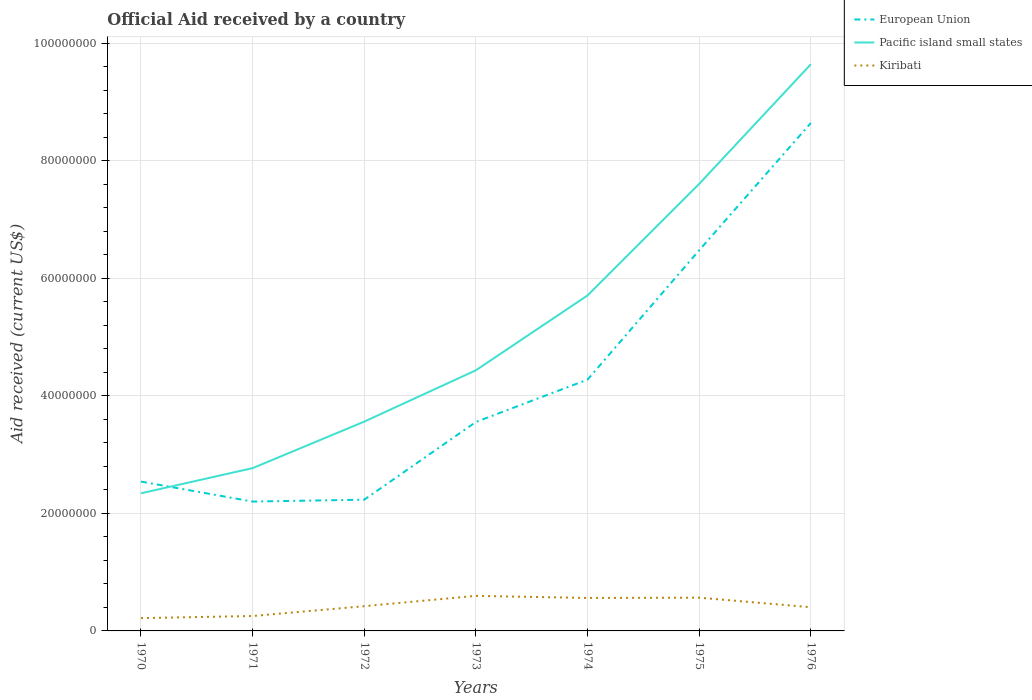Is the number of lines equal to the number of legend labels?
Offer a very short reply. Yes. Across all years, what is the maximum net official aid received in Kiribati?
Ensure brevity in your answer.  2.18e+06. In which year was the net official aid received in European Union maximum?
Ensure brevity in your answer.  1971. What is the total net official aid received in Kiribati in the graph?
Your answer should be compact. -2.03e+06. What is the difference between the highest and the second highest net official aid received in European Union?
Your response must be concise. 6.44e+07. How many lines are there?
Your response must be concise. 3. Does the graph contain any zero values?
Give a very brief answer. No. Does the graph contain grids?
Make the answer very short. Yes. Where does the legend appear in the graph?
Keep it short and to the point. Top right. How many legend labels are there?
Make the answer very short. 3. How are the legend labels stacked?
Make the answer very short. Vertical. What is the title of the graph?
Ensure brevity in your answer.  Official Aid received by a country. Does "Ukraine" appear as one of the legend labels in the graph?
Offer a very short reply. No. What is the label or title of the X-axis?
Your answer should be very brief. Years. What is the label or title of the Y-axis?
Make the answer very short. Aid received (current US$). What is the Aid received (current US$) in European Union in 1970?
Keep it short and to the point. 2.54e+07. What is the Aid received (current US$) in Pacific island small states in 1970?
Provide a succinct answer. 2.34e+07. What is the Aid received (current US$) in Kiribati in 1970?
Keep it short and to the point. 2.18e+06. What is the Aid received (current US$) in European Union in 1971?
Your answer should be very brief. 2.20e+07. What is the Aid received (current US$) of Pacific island small states in 1971?
Offer a terse response. 2.77e+07. What is the Aid received (current US$) of Kiribati in 1971?
Provide a short and direct response. 2.54e+06. What is the Aid received (current US$) of European Union in 1972?
Your response must be concise. 2.23e+07. What is the Aid received (current US$) of Pacific island small states in 1972?
Provide a short and direct response. 3.56e+07. What is the Aid received (current US$) in Kiribati in 1972?
Keep it short and to the point. 4.21e+06. What is the Aid received (current US$) of European Union in 1973?
Your answer should be very brief. 3.56e+07. What is the Aid received (current US$) of Pacific island small states in 1973?
Offer a very short reply. 4.44e+07. What is the Aid received (current US$) of Kiribati in 1973?
Ensure brevity in your answer.  5.97e+06. What is the Aid received (current US$) of European Union in 1974?
Your answer should be very brief. 4.28e+07. What is the Aid received (current US$) of Pacific island small states in 1974?
Ensure brevity in your answer.  5.71e+07. What is the Aid received (current US$) in Kiribati in 1974?
Provide a short and direct response. 5.61e+06. What is the Aid received (current US$) of European Union in 1975?
Your answer should be compact. 6.48e+07. What is the Aid received (current US$) in Pacific island small states in 1975?
Your answer should be very brief. 7.61e+07. What is the Aid received (current US$) in Kiribati in 1975?
Give a very brief answer. 5.66e+06. What is the Aid received (current US$) of European Union in 1976?
Your answer should be compact. 8.65e+07. What is the Aid received (current US$) of Pacific island small states in 1976?
Make the answer very short. 9.65e+07. What is the Aid received (current US$) of Kiribati in 1976?
Provide a succinct answer. 4.03e+06. Across all years, what is the maximum Aid received (current US$) of European Union?
Provide a succinct answer. 8.65e+07. Across all years, what is the maximum Aid received (current US$) of Pacific island small states?
Offer a very short reply. 9.65e+07. Across all years, what is the maximum Aid received (current US$) of Kiribati?
Your answer should be compact. 5.97e+06. Across all years, what is the minimum Aid received (current US$) of European Union?
Make the answer very short. 2.20e+07. Across all years, what is the minimum Aid received (current US$) of Pacific island small states?
Ensure brevity in your answer.  2.34e+07. Across all years, what is the minimum Aid received (current US$) of Kiribati?
Give a very brief answer. 2.18e+06. What is the total Aid received (current US$) in European Union in the graph?
Your response must be concise. 2.99e+08. What is the total Aid received (current US$) in Pacific island small states in the graph?
Your answer should be very brief. 3.61e+08. What is the total Aid received (current US$) in Kiribati in the graph?
Your response must be concise. 3.02e+07. What is the difference between the Aid received (current US$) in European Union in 1970 and that in 1971?
Keep it short and to the point. 3.40e+06. What is the difference between the Aid received (current US$) of Pacific island small states in 1970 and that in 1971?
Give a very brief answer. -4.28e+06. What is the difference between the Aid received (current US$) of Kiribati in 1970 and that in 1971?
Ensure brevity in your answer.  -3.60e+05. What is the difference between the Aid received (current US$) in European Union in 1970 and that in 1972?
Ensure brevity in your answer.  3.08e+06. What is the difference between the Aid received (current US$) in Pacific island small states in 1970 and that in 1972?
Your answer should be compact. -1.22e+07. What is the difference between the Aid received (current US$) in Kiribati in 1970 and that in 1972?
Make the answer very short. -2.03e+06. What is the difference between the Aid received (current US$) in European Union in 1970 and that in 1973?
Your response must be concise. -1.02e+07. What is the difference between the Aid received (current US$) in Pacific island small states in 1970 and that in 1973?
Provide a succinct answer. -2.09e+07. What is the difference between the Aid received (current US$) in Kiribati in 1970 and that in 1973?
Keep it short and to the point. -3.79e+06. What is the difference between the Aid received (current US$) of European Union in 1970 and that in 1974?
Your answer should be very brief. -1.74e+07. What is the difference between the Aid received (current US$) in Pacific island small states in 1970 and that in 1974?
Your answer should be very brief. -3.37e+07. What is the difference between the Aid received (current US$) in Kiribati in 1970 and that in 1974?
Your response must be concise. -3.43e+06. What is the difference between the Aid received (current US$) of European Union in 1970 and that in 1975?
Offer a terse response. -3.94e+07. What is the difference between the Aid received (current US$) of Pacific island small states in 1970 and that in 1975?
Provide a succinct answer. -5.27e+07. What is the difference between the Aid received (current US$) of Kiribati in 1970 and that in 1975?
Offer a terse response. -3.48e+06. What is the difference between the Aid received (current US$) of European Union in 1970 and that in 1976?
Make the answer very short. -6.10e+07. What is the difference between the Aid received (current US$) in Pacific island small states in 1970 and that in 1976?
Your response must be concise. -7.30e+07. What is the difference between the Aid received (current US$) in Kiribati in 1970 and that in 1976?
Provide a short and direct response. -1.85e+06. What is the difference between the Aid received (current US$) in European Union in 1971 and that in 1972?
Your answer should be very brief. -3.20e+05. What is the difference between the Aid received (current US$) of Pacific island small states in 1971 and that in 1972?
Ensure brevity in your answer.  -7.92e+06. What is the difference between the Aid received (current US$) of Kiribati in 1971 and that in 1972?
Provide a short and direct response. -1.67e+06. What is the difference between the Aid received (current US$) in European Union in 1971 and that in 1973?
Offer a terse response. -1.36e+07. What is the difference between the Aid received (current US$) in Pacific island small states in 1971 and that in 1973?
Give a very brief answer. -1.67e+07. What is the difference between the Aid received (current US$) of Kiribati in 1971 and that in 1973?
Keep it short and to the point. -3.43e+06. What is the difference between the Aid received (current US$) in European Union in 1971 and that in 1974?
Keep it short and to the point. -2.08e+07. What is the difference between the Aid received (current US$) in Pacific island small states in 1971 and that in 1974?
Your answer should be compact. -2.94e+07. What is the difference between the Aid received (current US$) in Kiribati in 1971 and that in 1974?
Offer a very short reply. -3.07e+06. What is the difference between the Aid received (current US$) of European Union in 1971 and that in 1975?
Give a very brief answer. -4.28e+07. What is the difference between the Aid received (current US$) of Pacific island small states in 1971 and that in 1975?
Give a very brief answer. -4.84e+07. What is the difference between the Aid received (current US$) in Kiribati in 1971 and that in 1975?
Your answer should be compact. -3.12e+06. What is the difference between the Aid received (current US$) in European Union in 1971 and that in 1976?
Provide a succinct answer. -6.44e+07. What is the difference between the Aid received (current US$) in Pacific island small states in 1971 and that in 1976?
Provide a succinct answer. -6.88e+07. What is the difference between the Aid received (current US$) of Kiribati in 1971 and that in 1976?
Keep it short and to the point. -1.49e+06. What is the difference between the Aid received (current US$) of European Union in 1972 and that in 1973?
Make the answer very short. -1.32e+07. What is the difference between the Aid received (current US$) in Pacific island small states in 1972 and that in 1973?
Your answer should be compact. -8.74e+06. What is the difference between the Aid received (current US$) in Kiribati in 1972 and that in 1973?
Provide a succinct answer. -1.76e+06. What is the difference between the Aid received (current US$) in European Union in 1972 and that in 1974?
Keep it short and to the point. -2.04e+07. What is the difference between the Aid received (current US$) of Pacific island small states in 1972 and that in 1974?
Your answer should be very brief. -2.15e+07. What is the difference between the Aid received (current US$) in Kiribati in 1972 and that in 1974?
Your response must be concise. -1.40e+06. What is the difference between the Aid received (current US$) of European Union in 1972 and that in 1975?
Give a very brief answer. -4.25e+07. What is the difference between the Aid received (current US$) of Pacific island small states in 1972 and that in 1975?
Your answer should be compact. -4.05e+07. What is the difference between the Aid received (current US$) in Kiribati in 1972 and that in 1975?
Give a very brief answer. -1.45e+06. What is the difference between the Aid received (current US$) in European Union in 1972 and that in 1976?
Ensure brevity in your answer.  -6.41e+07. What is the difference between the Aid received (current US$) of Pacific island small states in 1972 and that in 1976?
Provide a succinct answer. -6.08e+07. What is the difference between the Aid received (current US$) in Kiribati in 1972 and that in 1976?
Your response must be concise. 1.80e+05. What is the difference between the Aid received (current US$) in European Union in 1973 and that in 1974?
Your answer should be very brief. -7.21e+06. What is the difference between the Aid received (current US$) of Pacific island small states in 1973 and that in 1974?
Provide a succinct answer. -1.27e+07. What is the difference between the Aid received (current US$) in European Union in 1973 and that in 1975?
Keep it short and to the point. -2.92e+07. What is the difference between the Aid received (current US$) of Pacific island small states in 1973 and that in 1975?
Your response must be concise. -3.17e+07. What is the difference between the Aid received (current US$) of Kiribati in 1973 and that in 1975?
Give a very brief answer. 3.10e+05. What is the difference between the Aid received (current US$) in European Union in 1973 and that in 1976?
Give a very brief answer. -5.09e+07. What is the difference between the Aid received (current US$) in Pacific island small states in 1973 and that in 1976?
Ensure brevity in your answer.  -5.21e+07. What is the difference between the Aid received (current US$) in Kiribati in 1973 and that in 1976?
Provide a short and direct response. 1.94e+06. What is the difference between the Aid received (current US$) in European Union in 1974 and that in 1975?
Offer a very short reply. -2.20e+07. What is the difference between the Aid received (current US$) in Pacific island small states in 1974 and that in 1975?
Offer a terse response. -1.90e+07. What is the difference between the Aid received (current US$) in Kiribati in 1974 and that in 1975?
Your response must be concise. -5.00e+04. What is the difference between the Aid received (current US$) in European Union in 1974 and that in 1976?
Make the answer very short. -4.37e+07. What is the difference between the Aid received (current US$) in Pacific island small states in 1974 and that in 1976?
Your answer should be compact. -3.94e+07. What is the difference between the Aid received (current US$) in Kiribati in 1974 and that in 1976?
Offer a very short reply. 1.58e+06. What is the difference between the Aid received (current US$) in European Union in 1975 and that in 1976?
Give a very brief answer. -2.17e+07. What is the difference between the Aid received (current US$) in Pacific island small states in 1975 and that in 1976?
Your answer should be compact. -2.04e+07. What is the difference between the Aid received (current US$) in Kiribati in 1975 and that in 1976?
Provide a succinct answer. 1.63e+06. What is the difference between the Aid received (current US$) in European Union in 1970 and the Aid received (current US$) in Pacific island small states in 1971?
Your answer should be very brief. -2.29e+06. What is the difference between the Aid received (current US$) in European Union in 1970 and the Aid received (current US$) in Kiribati in 1971?
Your answer should be very brief. 2.29e+07. What is the difference between the Aid received (current US$) of Pacific island small states in 1970 and the Aid received (current US$) of Kiribati in 1971?
Provide a succinct answer. 2.09e+07. What is the difference between the Aid received (current US$) in European Union in 1970 and the Aid received (current US$) in Pacific island small states in 1972?
Provide a short and direct response. -1.02e+07. What is the difference between the Aid received (current US$) of European Union in 1970 and the Aid received (current US$) of Kiribati in 1972?
Offer a terse response. 2.12e+07. What is the difference between the Aid received (current US$) of Pacific island small states in 1970 and the Aid received (current US$) of Kiribati in 1972?
Ensure brevity in your answer.  1.92e+07. What is the difference between the Aid received (current US$) in European Union in 1970 and the Aid received (current US$) in Pacific island small states in 1973?
Your response must be concise. -1.90e+07. What is the difference between the Aid received (current US$) of European Union in 1970 and the Aid received (current US$) of Kiribati in 1973?
Keep it short and to the point. 1.94e+07. What is the difference between the Aid received (current US$) in Pacific island small states in 1970 and the Aid received (current US$) in Kiribati in 1973?
Make the answer very short. 1.75e+07. What is the difference between the Aid received (current US$) in European Union in 1970 and the Aid received (current US$) in Pacific island small states in 1974?
Offer a very short reply. -3.17e+07. What is the difference between the Aid received (current US$) in European Union in 1970 and the Aid received (current US$) in Kiribati in 1974?
Keep it short and to the point. 1.98e+07. What is the difference between the Aid received (current US$) of Pacific island small states in 1970 and the Aid received (current US$) of Kiribati in 1974?
Give a very brief answer. 1.78e+07. What is the difference between the Aid received (current US$) of European Union in 1970 and the Aid received (current US$) of Pacific island small states in 1975?
Provide a short and direct response. -5.07e+07. What is the difference between the Aid received (current US$) in European Union in 1970 and the Aid received (current US$) in Kiribati in 1975?
Your answer should be very brief. 1.98e+07. What is the difference between the Aid received (current US$) of Pacific island small states in 1970 and the Aid received (current US$) of Kiribati in 1975?
Ensure brevity in your answer.  1.78e+07. What is the difference between the Aid received (current US$) of European Union in 1970 and the Aid received (current US$) of Pacific island small states in 1976?
Ensure brevity in your answer.  -7.10e+07. What is the difference between the Aid received (current US$) in European Union in 1970 and the Aid received (current US$) in Kiribati in 1976?
Make the answer very short. 2.14e+07. What is the difference between the Aid received (current US$) of Pacific island small states in 1970 and the Aid received (current US$) of Kiribati in 1976?
Your answer should be compact. 1.94e+07. What is the difference between the Aid received (current US$) in European Union in 1971 and the Aid received (current US$) in Pacific island small states in 1972?
Your answer should be very brief. -1.36e+07. What is the difference between the Aid received (current US$) in European Union in 1971 and the Aid received (current US$) in Kiribati in 1972?
Keep it short and to the point. 1.78e+07. What is the difference between the Aid received (current US$) of Pacific island small states in 1971 and the Aid received (current US$) of Kiribati in 1972?
Keep it short and to the point. 2.35e+07. What is the difference between the Aid received (current US$) in European Union in 1971 and the Aid received (current US$) in Pacific island small states in 1973?
Offer a terse response. -2.24e+07. What is the difference between the Aid received (current US$) in European Union in 1971 and the Aid received (current US$) in Kiribati in 1973?
Make the answer very short. 1.60e+07. What is the difference between the Aid received (current US$) of Pacific island small states in 1971 and the Aid received (current US$) of Kiribati in 1973?
Provide a succinct answer. 2.17e+07. What is the difference between the Aid received (current US$) in European Union in 1971 and the Aid received (current US$) in Pacific island small states in 1974?
Offer a very short reply. -3.51e+07. What is the difference between the Aid received (current US$) in European Union in 1971 and the Aid received (current US$) in Kiribati in 1974?
Your answer should be very brief. 1.64e+07. What is the difference between the Aid received (current US$) of Pacific island small states in 1971 and the Aid received (current US$) of Kiribati in 1974?
Your answer should be very brief. 2.21e+07. What is the difference between the Aid received (current US$) in European Union in 1971 and the Aid received (current US$) in Pacific island small states in 1975?
Provide a succinct answer. -5.41e+07. What is the difference between the Aid received (current US$) in European Union in 1971 and the Aid received (current US$) in Kiribati in 1975?
Make the answer very short. 1.64e+07. What is the difference between the Aid received (current US$) in Pacific island small states in 1971 and the Aid received (current US$) in Kiribati in 1975?
Give a very brief answer. 2.20e+07. What is the difference between the Aid received (current US$) of European Union in 1971 and the Aid received (current US$) of Pacific island small states in 1976?
Offer a very short reply. -7.44e+07. What is the difference between the Aid received (current US$) in European Union in 1971 and the Aid received (current US$) in Kiribati in 1976?
Provide a succinct answer. 1.80e+07. What is the difference between the Aid received (current US$) of Pacific island small states in 1971 and the Aid received (current US$) of Kiribati in 1976?
Provide a succinct answer. 2.37e+07. What is the difference between the Aid received (current US$) of European Union in 1972 and the Aid received (current US$) of Pacific island small states in 1973?
Ensure brevity in your answer.  -2.20e+07. What is the difference between the Aid received (current US$) in European Union in 1972 and the Aid received (current US$) in Kiribati in 1973?
Provide a short and direct response. 1.64e+07. What is the difference between the Aid received (current US$) of Pacific island small states in 1972 and the Aid received (current US$) of Kiribati in 1973?
Provide a short and direct response. 2.97e+07. What is the difference between the Aid received (current US$) of European Union in 1972 and the Aid received (current US$) of Pacific island small states in 1974?
Keep it short and to the point. -3.48e+07. What is the difference between the Aid received (current US$) of European Union in 1972 and the Aid received (current US$) of Kiribati in 1974?
Keep it short and to the point. 1.67e+07. What is the difference between the Aid received (current US$) in Pacific island small states in 1972 and the Aid received (current US$) in Kiribati in 1974?
Offer a very short reply. 3.00e+07. What is the difference between the Aid received (current US$) in European Union in 1972 and the Aid received (current US$) in Pacific island small states in 1975?
Make the answer very short. -5.38e+07. What is the difference between the Aid received (current US$) in European Union in 1972 and the Aid received (current US$) in Kiribati in 1975?
Your response must be concise. 1.67e+07. What is the difference between the Aid received (current US$) in Pacific island small states in 1972 and the Aid received (current US$) in Kiribati in 1975?
Your answer should be very brief. 3.00e+07. What is the difference between the Aid received (current US$) of European Union in 1972 and the Aid received (current US$) of Pacific island small states in 1976?
Your response must be concise. -7.41e+07. What is the difference between the Aid received (current US$) of European Union in 1972 and the Aid received (current US$) of Kiribati in 1976?
Ensure brevity in your answer.  1.83e+07. What is the difference between the Aid received (current US$) of Pacific island small states in 1972 and the Aid received (current US$) of Kiribati in 1976?
Your response must be concise. 3.16e+07. What is the difference between the Aid received (current US$) in European Union in 1973 and the Aid received (current US$) in Pacific island small states in 1974?
Provide a succinct answer. -2.15e+07. What is the difference between the Aid received (current US$) in European Union in 1973 and the Aid received (current US$) in Kiribati in 1974?
Offer a very short reply. 3.00e+07. What is the difference between the Aid received (current US$) in Pacific island small states in 1973 and the Aid received (current US$) in Kiribati in 1974?
Offer a terse response. 3.88e+07. What is the difference between the Aid received (current US$) in European Union in 1973 and the Aid received (current US$) in Pacific island small states in 1975?
Your answer should be compact. -4.05e+07. What is the difference between the Aid received (current US$) in European Union in 1973 and the Aid received (current US$) in Kiribati in 1975?
Offer a very short reply. 2.99e+07. What is the difference between the Aid received (current US$) of Pacific island small states in 1973 and the Aid received (current US$) of Kiribati in 1975?
Your response must be concise. 3.87e+07. What is the difference between the Aid received (current US$) in European Union in 1973 and the Aid received (current US$) in Pacific island small states in 1976?
Make the answer very short. -6.09e+07. What is the difference between the Aid received (current US$) in European Union in 1973 and the Aid received (current US$) in Kiribati in 1976?
Offer a very short reply. 3.15e+07. What is the difference between the Aid received (current US$) in Pacific island small states in 1973 and the Aid received (current US$) in Kiribati in 1976?
Offer a very short reply. 4.03e+07. What is the difference between the Aid received (current US$) of European Union in 1974 and the Aid received (current US$) of Pacific island small states in 1975?
Give a very brief answer. -3.33e+07. What is the difference between the Aid received (current US$) in European Union in 1974 and the Aid received (current US$) in Kiribati in 1975?
Make the answer very short. 3.71e+07. What is the difference between the Aid received (current US$) of Pacific island small states in 1974 and the Aid received (current US$) of Kiribati in 1975?
Your answer should be very brief. 5.14e+07. What is the difference between the Aid received (current US$) of European Union in 1974 and the Aid received (current US$) of Pacific island small states in 1976?
Offer a very short reply. -5.37e+07. What is the difference between the Aid received (current US$) in European Union in 1974 and the Aid received (current US$) in Kiribati in 1976?
Keep it short and to the point. 3.88e+07. What is the difference between the Aid received (current US$) in Pacific island small states in 1974 and the Aid received (current US$) in Kiribati in 1976?
Offer a terse response. 5.31e+07. What is the difference between the Aid received (current US$) of European Union in 1975 and the Aid received (current US$) of Pacific island small states in 1976?
Keep it short and to the point. -3.17e+07. What is the difference between the Aid received (current US$) in European Union in 1975 and the Aid received (current US$) in Kiribati in 1976?
Your answer should be very brief. 6.08e+07. What is the difference between the Aid received (current US$) in Pacific island small states in 1975 and the Aid received (current US$) in Kiribati in 1976?
Keep it short and to the point. 7.21e+07. What is the average Aid received (current US$) of European Union per year?
Keep it short and to the point. 4.28e+07. What is the average Aid received (current US$) of Pacific island small states per year?
Offer a very short reply. 5.15e+07. What is the average Aid received (current US$) in Kiribati per year?
Make the answer very short. 4.31e+06. In the year 1970, what is the difference between the Aid received (current US$) in European Union and Aid received (current US$) in Pacific island small states?
Ensure brevity in your answer.  1.99e+06. In the year 1970, what is the difference between the Aid received (current US$) in European Union and Aid received (current US$) in Kiribati?
Make the answer very short. 2.32e+07. In the year 1970, what is the difference between the Aid received (current US$) in Pacific island small states and Aid received (current US$) in Kiribati?
Provide a succinct answer. 2.12e+07. In the year 1971, what is the difference between the Aid received (current US$) in European Union and Aid received (current US$) in Pacific island small states?
Give a very brief answer. -5.69e+06. In the year 1971, what is the difference between the Aid received (current US$) in European Union and Aid received (current US$) in Kiribati?
Provide a succinct answer. 1.95e+07. In the year 1971, what is the difference between the Aid received (current US$) in Pacific island small states and Aid received (current US$) in Kiribati?
Give a very brief answer. 2.52e+07. In the year 1972, what is the difference between the Aid received (current US$) of European Union and Aid received (current US$) of Pacific island small states?
Make the answer very short. -1.33e+07. In the year 1972, what is the difference between the Aid received (current US$) in European Union and Aid received (current US$) in Kiribati?
Offer a terse response. 1.81e+07. In the year 1972, what is the difference between the Aid received (current US$) in Pacific island small states and Aid received (current US$) in Kiribati?
Your answer should be compact. 3.14e+07. In the year 1973, what is the difference between the Aid received (current US$) in European Union and Aid received (current US$) in Pacific island small states?
Your response must be concise. -8.80e+06. In the year 1973, what is the difference between the Aid received (current US$) of European Union and Aid received (current US$) of Kiribati?
Provide a succinct answer. 2.96e+07. In the year 1973, what is the difference between the Aid received (current US$) in Pacific island small states and Aid received (current US$) in Kiribati?
Offer a very short reply. 3.84e+07. In the year 1974, what is the difference between the Aid received (current US$) in European Union and Aid received (current US$) in Pacific island small states?
Ensure brevity in your answer.  -1.43e+07. In the year 1974, what is the difference between the Aid received (current US$) of European Union and Aid received (current US$) of Kiribati?
Offer a very short reply. 3.72e+07. In the year 1974, what is the difference between the Aid received (current US$) in Pacific island small states and Aid received (current US$) in Kiribati?
Make the answer very short. 5.15e+07. In the year 1975, what is the difference between the Aid received (current US$) in European Union and Aid received (current US$) in Pacific island small states?
Make the answer very short. -1.13e+07. In the year 1975, what is the difference between the Aid received (current US$) of European Union and Aid received (current US$) of Kiribati?
Your answer should be very brief. 5.91e+07. In the year 1975, what is the difference between the Aid received (current US$) of Pacific island small states and Aid received (current US$) of Kiribati?
Your answer should be compact. 7.04e+07. In the year 1976, what is the difference between the Aid received (current US$) in European Union and Aid received (current US$) in Pacific island small states?
Make the answer very short. -1.00e+07. In the year 1976, what is the difference between the Aid received (current US$) of European Union and Aid received (current US$) of Kiribati?
Offer a terse response. 8.24e+07. In the year 1976, what is the difference between the Aid received (current US$) in Pacific island small states and Aid received (current US$) in Kiribati?
Ensure brevity in your answer.  9.24e+07. What is the ratio of the Aid received (current US$) in European Union in 1970 to that in 1971?
Give a very brief answer. 1.15. What is the ratio of the Aid received (current US$) in Pacific island small states in 1970 to that in 1971?
Your answer should be very brief. 0.85. What is the ratio of the Aid received (current US$) in Kiribati in 1970 to that in 1971?
Ensure brevity in your answer.  0.86. What is the ratio of the Aid received (current US$) of European Union in 1970 to that in 1972?
Give a very brief answer. 1.14. What is the ratio of the Aid received (current US$) of Pacific island small states in 1970 to that in 1972?
Ensure brevity in your answer.  0.66. What is the ratio of the Aid received (current US$) in Kiribati in 1970 to that in 1972?
Provide a short and direct response. 0.52. What is the ratio of the Aid received (current US$) in European Union in 1970 to that in 1973?
Keep it short and to the point. 0.71. What is the ratio of the Aid received (current US$) of Pacific island small states in 1970 to that in 1973?
Provide a succinct answer. 0.53. What is the ratio of the Aid received (current US$) of Kiribati in 1970 to that in 1973?
Ensure brevity in your answer.  0.37. What is the ratio of the Aid received (current US$) of European Union in 1970 to that in 1974?
Your response must be concise. 0.59. What is the ratio of the Aid received (current US$) of Pacific island small states in 1970 to that in 1974?
Your answer should be compact. 0.41. What is the ratio of the Aid received (current US$) of Kiribati in 1970 to that in 1974?
Make the answer very short. 0.39. What is the ratio of the Aid received (current US$) in European Union in 1970 to that in 1975?
Your response must be concise. 0.39. What is the ratio of the Aid received (current US$) of Pacific island small states in 1970 to that in 1975?
Your response must be concise. 0.31. What is the ratio of the Aid received (current US$) in Kiribati in 1970 to that in 1975?
Give a very brief answer. 0.39. What is the ratio of the Aid received (current US$) of European Union in 1970 to that in 1976?
Give a very brief answer. 0.29. What is the ratio of the Aid received (current US$) in Pacific island small states in 1970 to that in 1976?
Keep it short and to the point. 0.24. What is the ratio of the Aid received (current US$) in Kiribati in 1970 to that in 1976?
Give a very brief answer. 0.54. What is the ratio of the Aid received (current US$) in European Union in 1971 to that in 1972?
Offer a terse response. 0.99. What is the ratio of the Aid received (current US$) of Pacific island small states in 1971 to that in 1972?
Your response must be concise. 0.78. What is the ratio of the Aid received (current US$) in Kiribati in 1971 to that in 1972?
Provide a short and direct response. 0.6. What is the ratio of the Aid received (current US$) of European Union in 1971 to that in 1973?
Your answer should be compact. 0.62. What is the ratio of the Aid received (current US$) in Pacific island small states in 1971 to that in 1973?
Your response must be concise. 0.62. What is the ratio of the Aid received (current US$) in Kiribati in 1971 to that in 1973?
Ensure brevity in your answer.  0.43. What is the ratio of the Aid received (current US$) of European Union in 1971 to that in 1974?
Provide a succinct answer. 0.51. What is the ratio of the Aid received (current US$) of Pacific island small states in 1971 to that in 1974?
Your answer should be compact. 0.49. What is the ratio of the Aid received (current US$) of Kiribati in 1971 to that in 1974?
Provide a short and direct response. 0.45. What is the ratio of the Aid received (current US$) in European Union in 1971 to that in 1975?
Make the answer very short. 0.34. What is the ratio of the Aid received (current US$) in Pacific island small states in 1971 to that in 1975?
Offer a very short reply. 0.36. What is the ratio of the Aid received (current US$) of Kiribati in 1971 to that in 1975?
Provide a succinct answer. 0.45. What is the ratio of the Aid received (current US$) of European Union in 1971 to that in 1976?
Offer a terse response. 0.25. What is the ratio of the Aid received (current US$) of Pacific island small states in 1971 to that in 1976?
Your answer should be very brief. 0.29. What is the ratio of the Aid received (current US$) in Kiribati in 1971 to that in 1976?
Provide a succinct answer. 0.63. What is the ratio of the Aid received (current US$) in European Union in 1972 to that in 1973?
Provide a succinct answer. 0.63. What is the ratio of the Aid received (current US$) of Pacific island small states in 1972 to that in 1973?
Ensure brevity in your answer.  0.8. What is the ratio of the Aid received (current US$) of Kiribati in 1972 to that in 1973?
Keep it short and to the point. 0.71. What is the ratio of the Aid received (current US$) in European Union in 1972 to that in 1974?
Keep it short and to the point. 0.52. What is the ratio of the Aid received (current US$) in Pacific island small states in 1972 to that in 1974?
Your answer should be compact. 0.62. What is the ratio of the Aid received (current US$) in Kiribati in 1972 to that in 1974?
Provide a short and direct response. 0.75. What is the ratio of the Aid received (current US$) of European Union in 1972 to that in 1975?
Offer a terse response. 0.34. What is the ratio of the Aid received (current US$) in Pacific island small states in 1972 to that in 1975?
Ensure brevity in your answer.  0.47. What is the ratio of the Aid received (current US$) of Kiribati in 1972 to that in 1975?
Provide a succinct answer. 0.74. What is the ratio of the Aid received (current US$) in European Union in 1972 to that in 1976?
Provide a succinct answer. 0.26. What is the ratio of the Aid received (current US$) in Pacific island small states in 1972 to that in 1976?
Keep it short and to the point. 0.37. What is the ratio of the Aid received (current US$) of Kiribati in 1972 to that in 1976?
Your answer should be very brief. 1.04. What is the ratio of the Aid received (current US$) in European Union in 1973 to that in 1974?
Offer a terse response. 0.83. What is the ratio of the Aid received (current US$) in Pacific island small states in 1973 to that in 1974?
Keep it short and to the point. 0.78. What is the ratio of the Aid received (current US$) in Kiribati in 1973 to that in 1974?
Give a very brief answer. 1.06. What is the ratio of the Aid received (current US$) of European Union in 1973 to that in 1975?
Provide a short and direct response. 0.55. What is the ratio of the Aid received (current US$) in Pacific island small states in 1973 to that in 1975?
Give a very brief answer. 0.58. What is the ratio of the Aid received (current US$) in Kiribati in 1973 to that in 1975?
Keep it short and to the point. 1.05. What is the ratio of the Aid received (current US$) of European Union in 1973 to that in 1976?
Offer a very short reply. 0.41. What is the ratio of the Aid received (current US$) in Pacific island small states in 1973 to that in 1976?
Make the answer very short. 0.46. What is the ratio of the Aid received (current US$) in Kiribati in 1973 to that in 1976?
Provide a short and direct response. 1.48. What is the ratio of the Aid received (current US$) of European Union in 1974 to that in 1975?
Provide a succinct answer. 0.66. What is the ratio of the Aid received (current US$) of Pacific island small states in 1974 to that in 1975?
Keep it short and to the point. 0.75. What is the ratio of the Aid received (current US$) of Kiribati in 1974 to that in 1975?
Provide a succinct answer. 0.99. What is the ratio of the Aid received (current US$) of European Union in 1974 to that in 1976?
Provide a short and direct response. 0.49. What is the ratio of the Aid received (current US$) of Pacific island small states in 1974 to that in 1976?
Keep it short and to the point. 0.59. What is the ratio of the Aid received (current US$) of Kiribati in 1974 to that in 1976?
Provide a short and direct response. 1.39. What is the ratio of the Aid received (current US$) in European Union in 1975 to that in 1976?
Make the answer very short. 0.75. What is the ratio of the Aid received (current US$) of Pacific island small states in 1975 to that in 1976?
Provide a short and direct response. 0.79. What is the ratio of the Aid received (current US$) of Kiribati in 1975 to that in 1976?
Keep it short and to the point. 1.4. What is the difference between the highest and the second highest Aid received (current US$) of European Union?
Keep it short and to the point. 2.17e+07. What is the difference between the highest and the second highest Aid received (current US$) in Pacific island small states?
Ensure brevity in your answer.  2.04e+07. What is the difference between the highest and the lowest Aid received (current US$) of European Union?
Give a very brief answer. 6.44e+07. What is the difference between the highest and the lowest Aid received (current US$) in Pacific island small states?
Offer a terse response. 7.30e+07. What is the difference between the highest and the lowest Aid received (current US$) of Kiribati?
Your answer should be compact. 3.79e+06. 